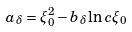<formula> <loc_0><loc_0><loc_500><loc_500>a _ { \delta } = \xi _ { 0 } ^ { 2 } - b _ { \delta } \ln c \xi _ { 0 }</formula> 